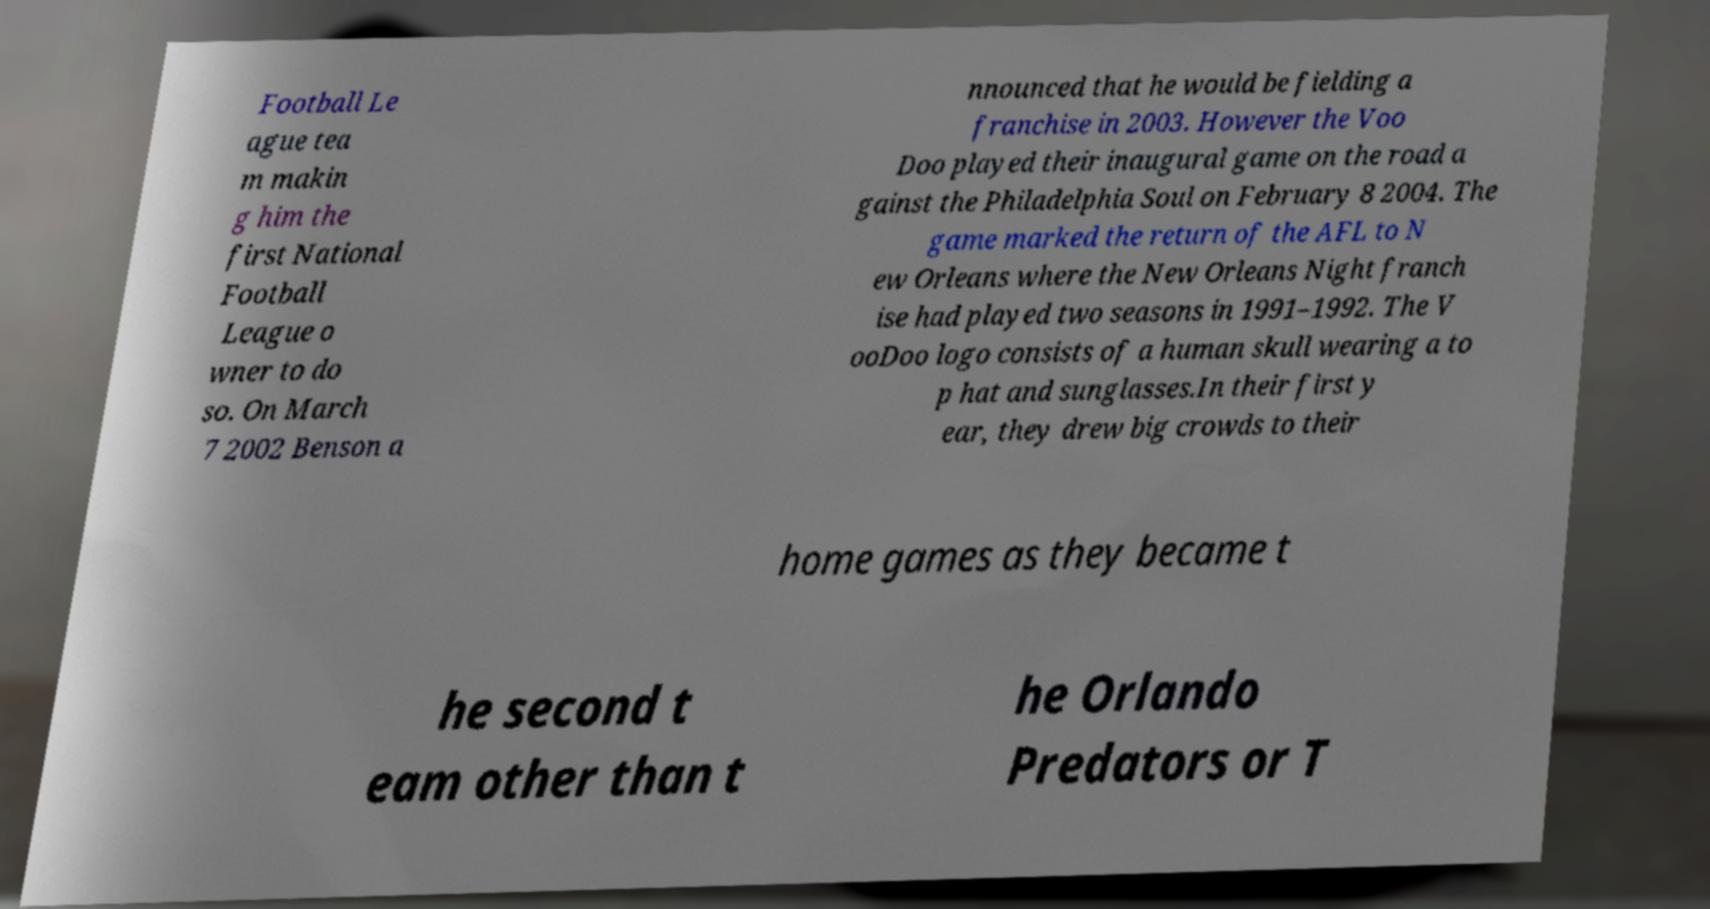I need the written content from this picture converted into text. Can you do that? Football Le ague tea m makin g him the first National Football League o wner to do so. On March 7 2002 Benson a nnounced that he would be fielding a franchise in 2003. However the Voo Doo played their inaugural game on the road a gainst the Philadelphia Soul on February 8 2004. The game marked the return of the AFL to N ew Orleans where the New Orleans Night franch ise had played two seasons in 1991–1992. The V ooDoo logo consists of a human skull wearing a to p hat and sunglasses.In their first y ear, they drew big crowds to their home games as they became t he second t eam other than t he Orlando Predators or T 